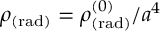Convert formula to latex. <formula><loc_0><loc_0><loc_500><loc_500>\rho _ { ( r a d ) } = \rho _ { ( r a d ) } ^ { ( 0 ) } / a ^ { 4 }</formula> 